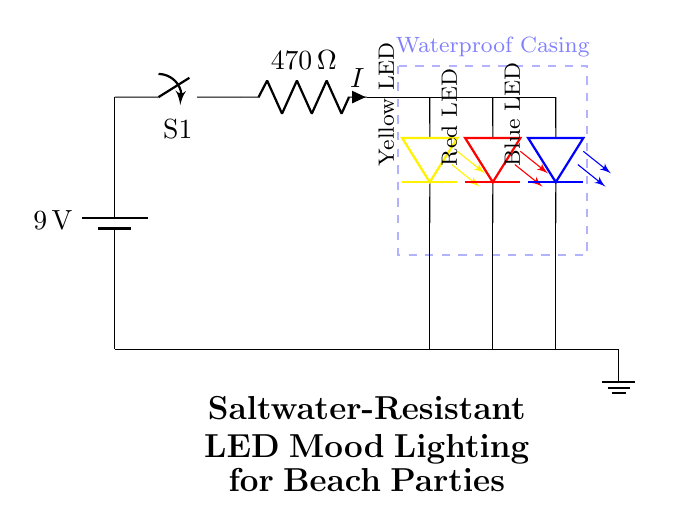What is the voltage of this circuit? The voltage is 9 volts, which can be found by looking at the battery symbol labeled with the value next to it in the circuit diagram.
Answer: 9 volts How many resistors are in the circuit? There is one resistor, which is labeled with its value and symbol in the circuit diagram.
Answer: One What is the total number of LEDs used? The circuit diagram shows three LEDs, each represented by a specific colored symbol in parallel connection.
Answer: Three What is the resistance value in the circuit? The resistance value is 470 ohms, which is noted beside the resistor in the circuit diagram.
Answer: 470 ohms Explain how the LEDs are configured in the circuit. The LEDs are connected in parallel; each LED is wired parallel to one another, meaning they share the same voltage (9 volts) from the resistor while having individual current flows. This can be identified by the separate connections leading from the resistor to each LED.
Answer: Parallel Is the casing for the circuit waterproof? Yes, the waterproof casing is indicated in the circuit diagram with a dashed rectangle labeled as "Waterproof Casing," providing protection for the circuit components from the saltwater environment.
Answer: Yes 